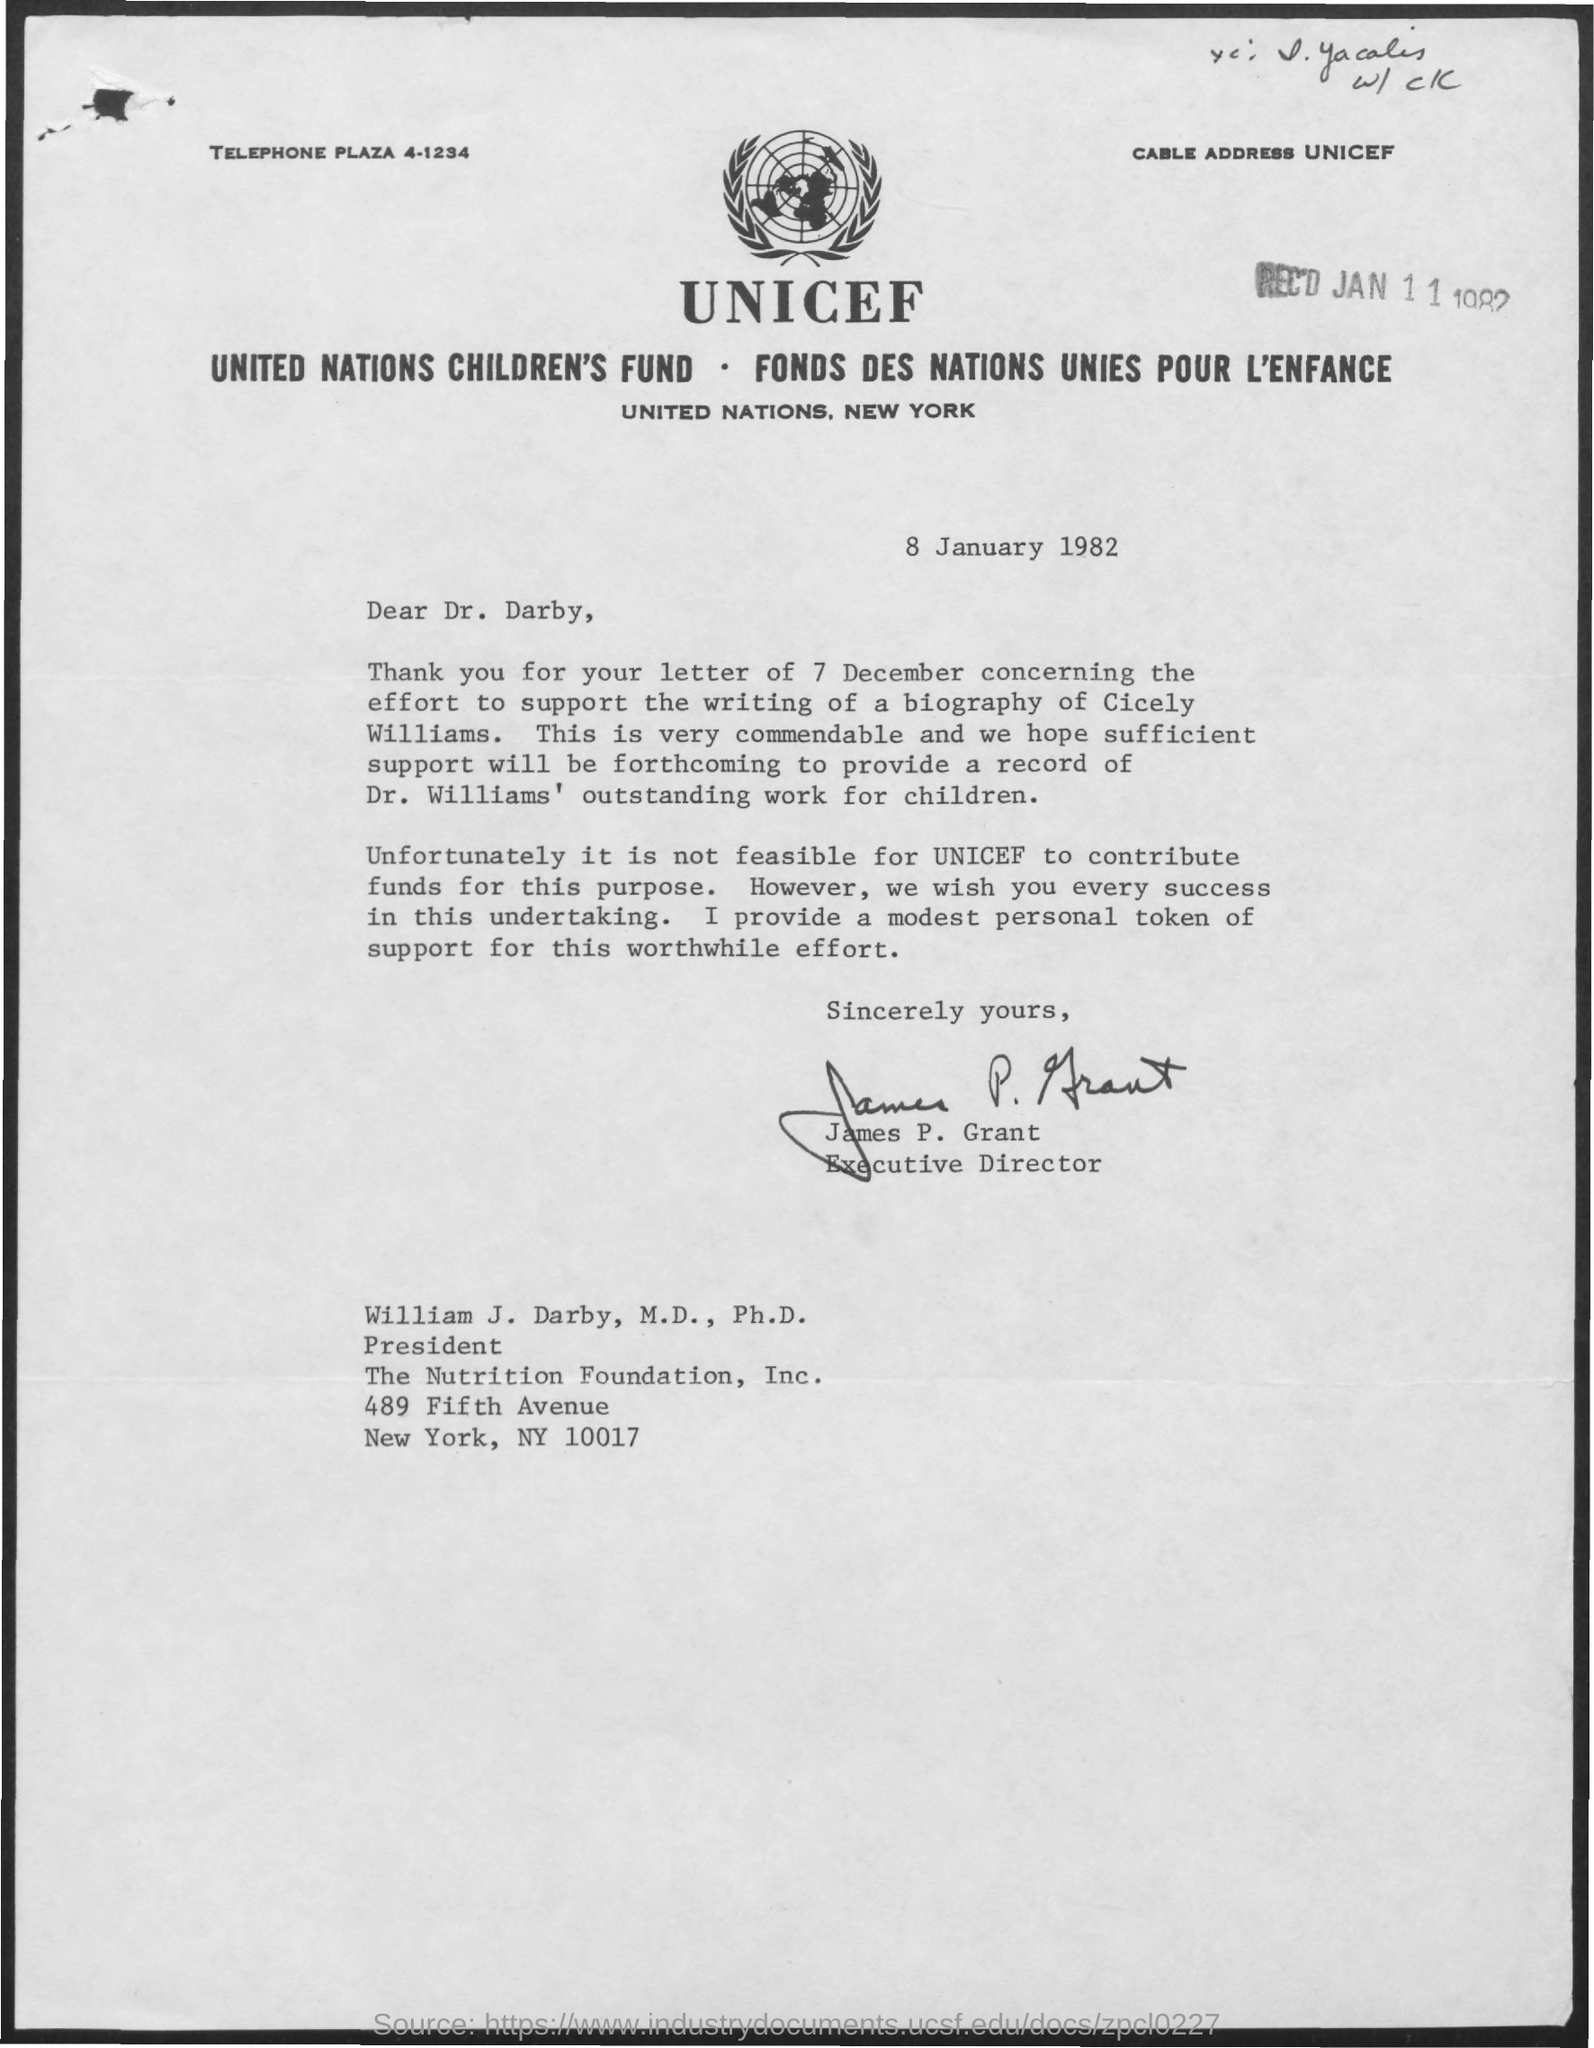Who is the Executive Director who signed the document?
Provide a succinct answer. James P. Grant. Who is mentioned as Dear in this document?
Offer a terse response. Dr. Darby. 